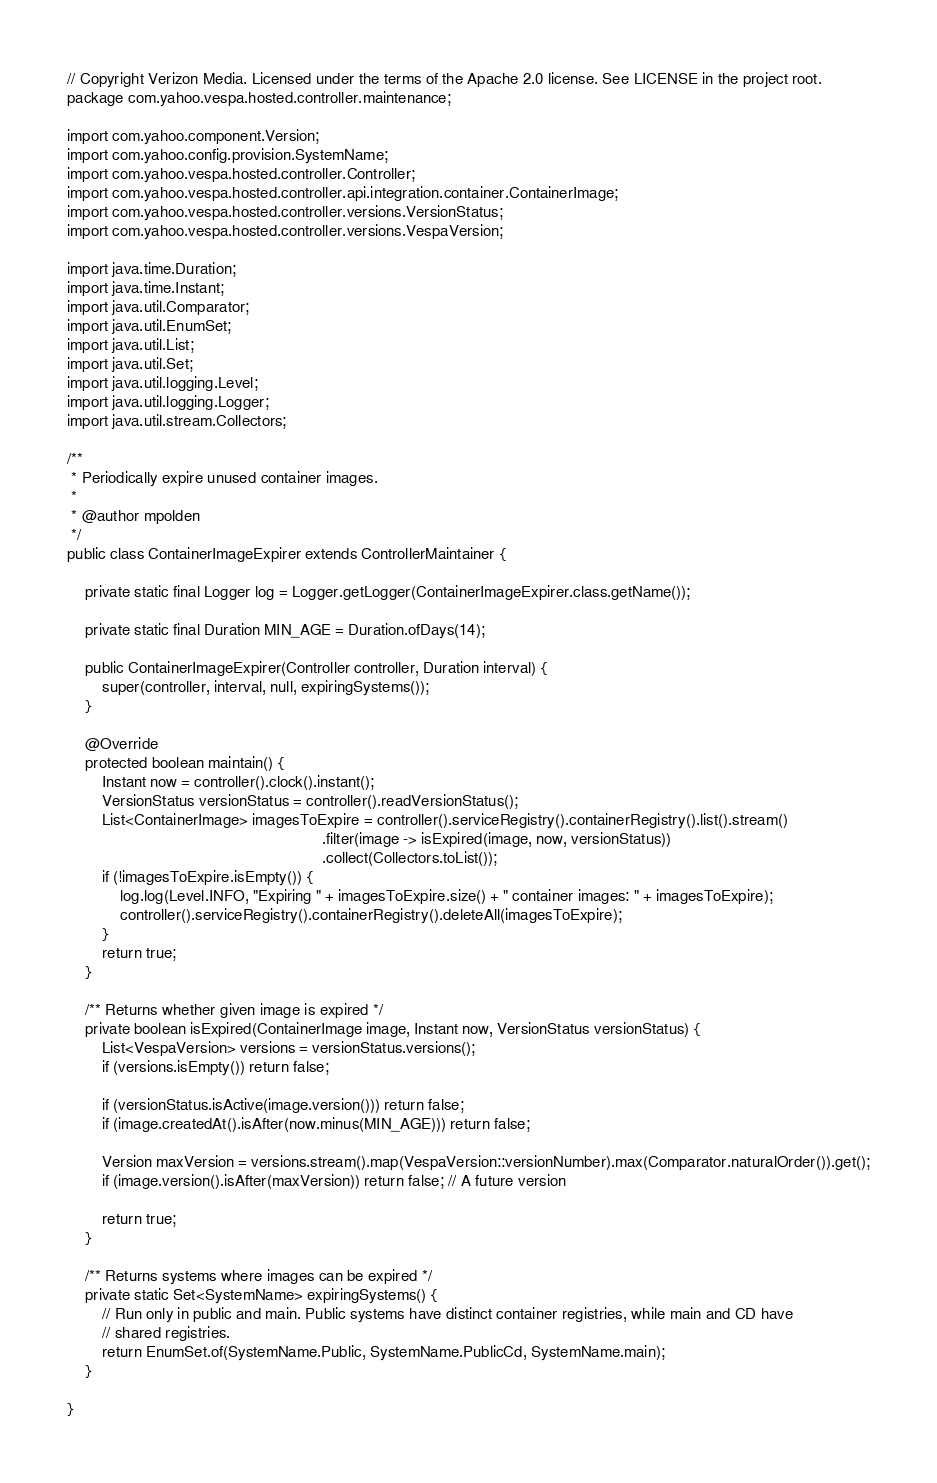<code> <loc_0><loc_0><loc_500><loc_500><_Java_>// Copyright Verizon Media. Licensed under the terms of the Apache 2.0 license. See LICENSE in the project root.
package com.yahoo.vespa.hosted.controller.maintenance;

import com.yahoo.component.Version;
import com.yahoo.config.provision.SystemName;
import com.yahoo.vespa.hosted.controller.Controller;
import com.yahoo.vespa.hosted.controller.api.integration.container.ContainerImage;
import com.yahoo.vespa.hosted.controller.versions.VersionStatus;
import com.yahoo.vespa.hosted.controller.versions.VespaVersion;

import java.time.Duration;
import java.time.Instant;
import java.util.Comparator;
import java.util.EnumSet;
import java.util.List;
import java.util.Set;
import java.util.logging.Level;
import java.util.logging.Logger;
import java.util.stream.Collectors;

/**
 * Periodically expire unused container images.
 *
 * @author mpolden
 */
public class ContainerImageExpirer extends ControllerMaintainer {

    private static final Logger log = Logger.getLogger(ContainerImageExpirer.class.getName());

    private static final Duration MIN_AGE = Duration.ofDays(14);

    public ContainerImageExpirer(Controller controller, Duration interval) {
        super(controller, interval, null, expiringSystems());
    }

    @Override
    protected boolean maintain() {
        Instant now = controller().clock().instant();
        VersionStatus versionStatus = controller().readVersionStatus();
        List<ContainerImage> imagesToExpire = controller().serviceRegistry().containerRegistry().list().stream()
                                                          .filter(image -> isExpired(image, now, versionStatus))
                                                          .collect(Collectors.toList());
        if (!imagesToExpire.isEmpty()) {
            log.log(Level.INFO, "Expiring " + imagesToExpire.size() + " container images: " + imagesToExpire);
            controller().serviceRegistry().containerRegistry().deleteAll(imagesToExpire);
        }
        return true;
    }

    /** Returns whether given image is expired */
    private boolean isExpired(ContainerImage image, Instant now, VersionStatus versionStatus) {
        List<VespaVersion> versions = versionStatus.versions();
        if (versions.isEmpty()) return false;

        if (versionStatus.isActive(image.version())) return false;
        if (image.createdAt().isAfter(now.minus(MIN_AGE))) return false;

        Version maxVersion = versions.stream().map(VespaVersion::versionNumber).max(Comparator.naturalOrder()).get();
        if (image.version().isAfter(maxVersion)) return false; // A future version

        return true;
    }

    /** Returns systems where images can be expired */
    private static Set<SystemName> expiringSystems() {
        // Run only in public and main. Public systems have distinct container registries, while main and CD have
        // shared registries.
        return EnumSet.of(SystemName.Public, SystemName.PublicCd, SystemName.main);
    }

}
</code> 